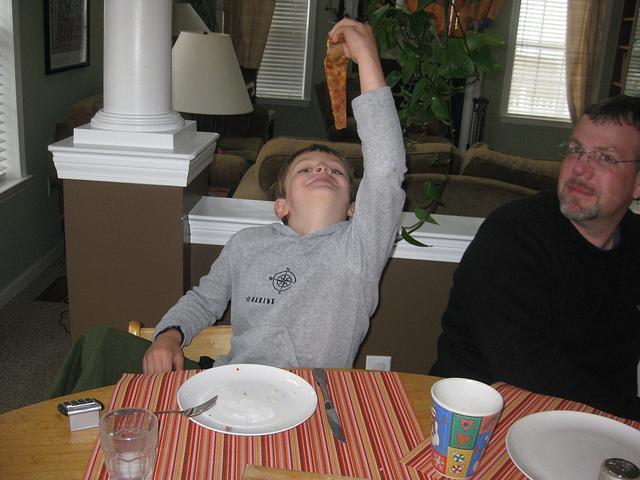How many cups are there?
Give a very brief answer. 2. How many couches can you see?
Give a very brief answer. 2. How many people can you see?
Give a very brief answer. 2. How many giraffes are there?
Give a very brief answer. 0. 